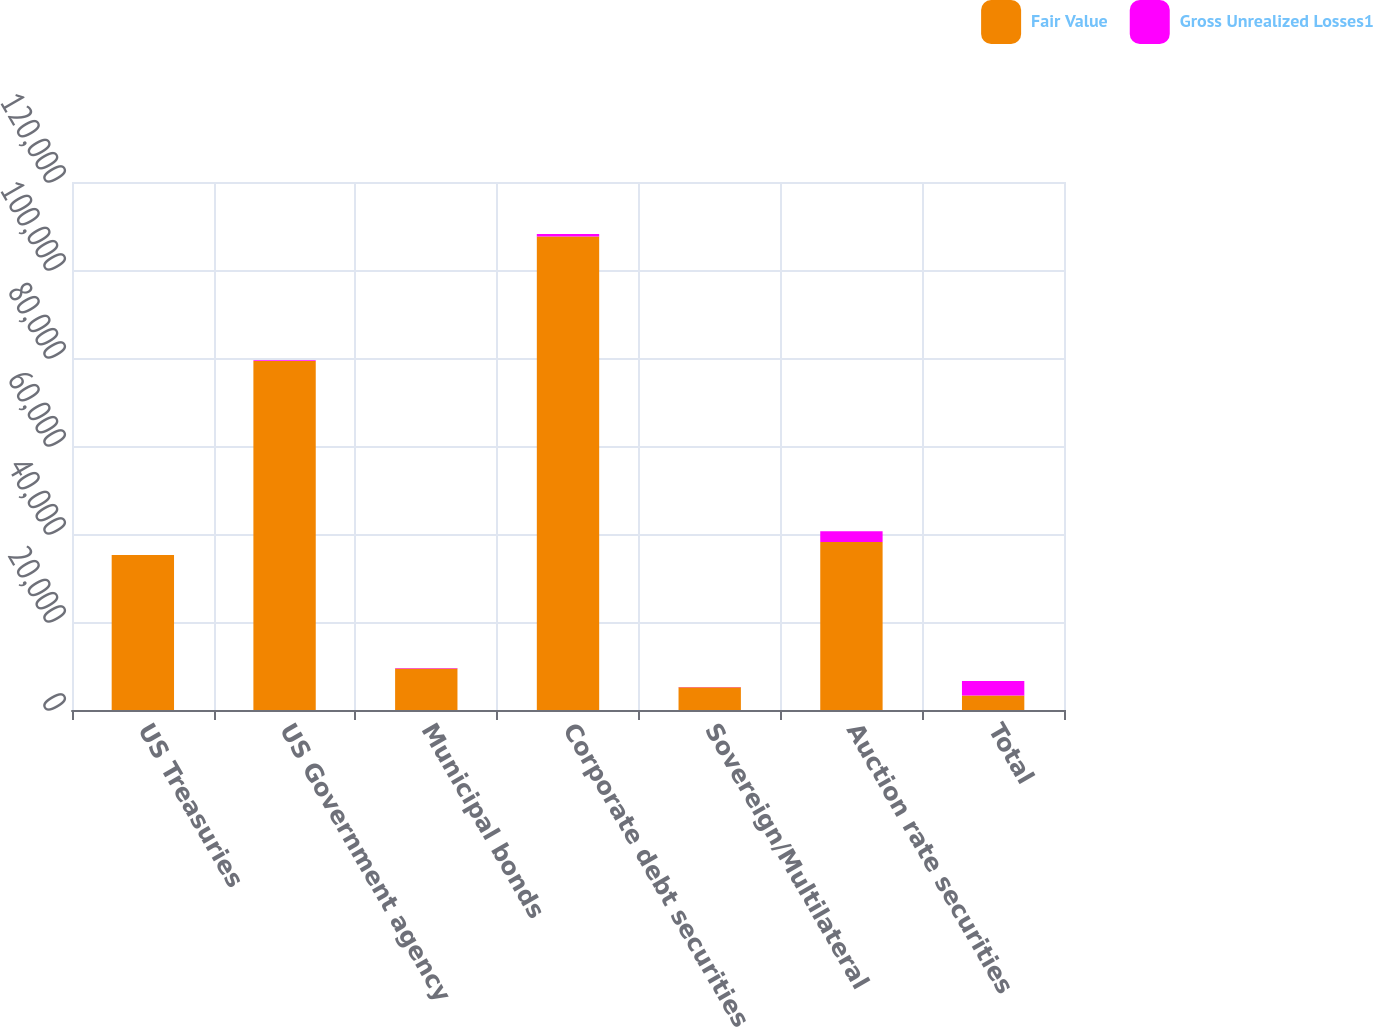Convert chart to OTSL. <chart><loc_0><loc_0><loc_500><loc_500><stacked_bar_chart><ecel><fcel>US Treasuries<fcel>US Government agency<fcel>Municipal bonds<fcel>Corporate debt securities<fcel>Sovereign/Multilateral<fcel>Auction rate securities<fcel>Total<nl><fcel>Fair Value<fcel>35224<fcel>79345<fcel>9455<fcel>107597<fcel>5188<fcel>38168<fcel>3300<nl><fcel>Gross Unrealized Losses1<fcel>7<fcel>155<fcel>68<fcel>557<fcel>31<fcel>2482<fcel>3300<nl></chart> 